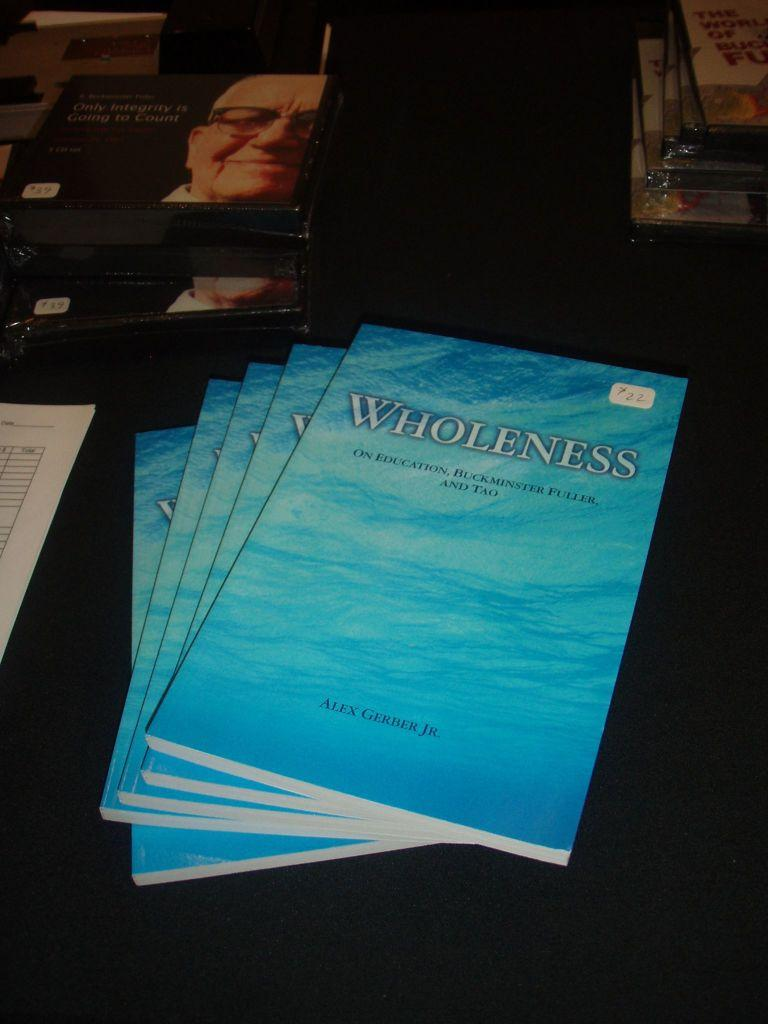<image>
Give a short and clear explanation of the subsequent image. A stack of books are on a table and are titled Wholeness. 